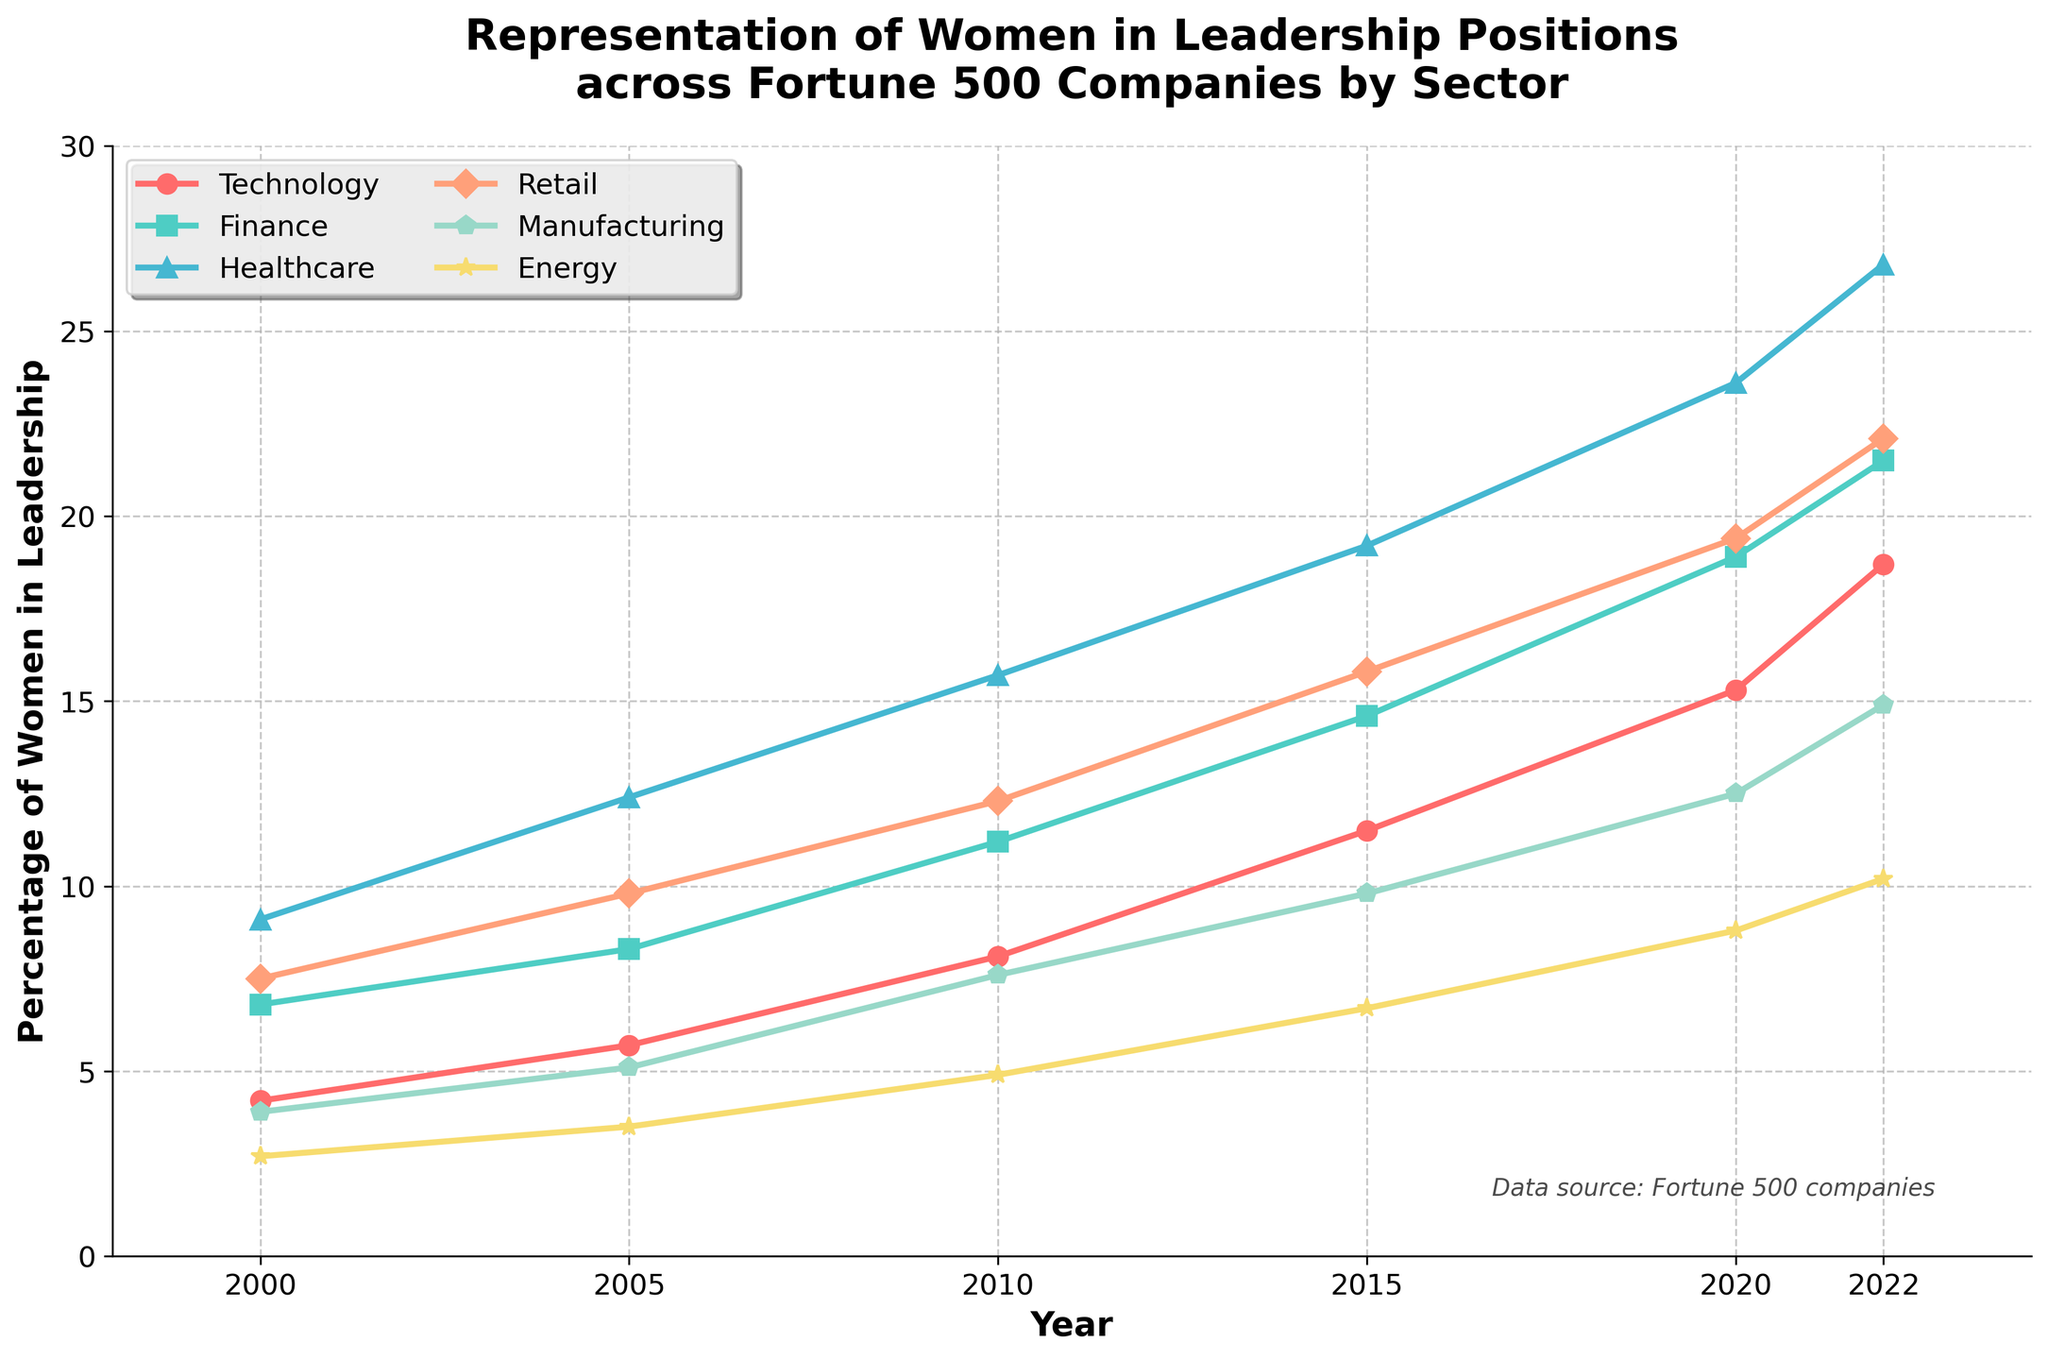Which sector had the highest percentage of women in leadership positions in 2022? Looking at the line chart in 2022, the Healthcare sector shows the highest percentage of women in leadership positions.
Answer: Healthcare Which two sectors showed the most significant increase in the percentage of women in leadership from 2000 to 2022? By subtracting the 2000 values from the 2022 values and comparing the differences, we see Healthcare and Technology have the highest increases (26.8 - 9.1 = 17.7 and 18.7 - 4.2 = 14.5, respectively).
Answer: Healthcare and Technology In what year did the Technology sector surpass a 10% representation of women in leadership positions? The Technology line crosses the 10% mark between 2010 and 2015. Checking the exact data, it's clear that in 2015, Technology was at 11.5%.
Answer: 2015 Which sectors had a slower increase in women leadership, with less than a 10% increase from 2000 to 2022? By calculating the differences from 2000 to 2022, Finance (14.7%), Manufacturing (11.0%), and Energy (7.5%) had increases. Only Energy has an increase less than 10% (10.2 - 2.7 = 7.5).
Answer: Energy By how much did the percentage of women in leadership positions in the Retail sector increase from 2010 to 2020? Subtracting the 2010 value from the 2020 value for Retail, we find the increase to be 19.4 - 12.3 = 7.1.
Answer: 7.1 Which sector had the biggest gap in percentage difference compared to the Healthcare sector in 2022? In 2022, subtract each sector's percentage from Healthcare's 26.8%. The Energy sector shows the largest gap: 26.8 - 10.2 = 16.6.
Answer: Energy What was the average percentage of women in leadership positions across all sectors in 2022? Summing up the 2022 values (18.7 + 21.5 + 26.8 + 22.1 + 14.9 + 10.2) and dividing by the number of sectors (6), we get (26.8 + 22.1 + 21.5 + 18.7 + 14.9 + 10.2) / 6 = 114.2 / 6 = 19.03.
Answer: 19.03 By what percentage did the Energy sector increase its representation of women in leadership from 2000 to 2020, and is this rate higher or lower than the Finance sector during the same period? The increase for Energy: ((8.8 - 2.7) / 2.7) * 100% = 225.9%. For Finance: ((18.9 - 6.8) / 6.8) * 100% = 177.9%. The Energy sector's rate is higher.
Answer: Higher 